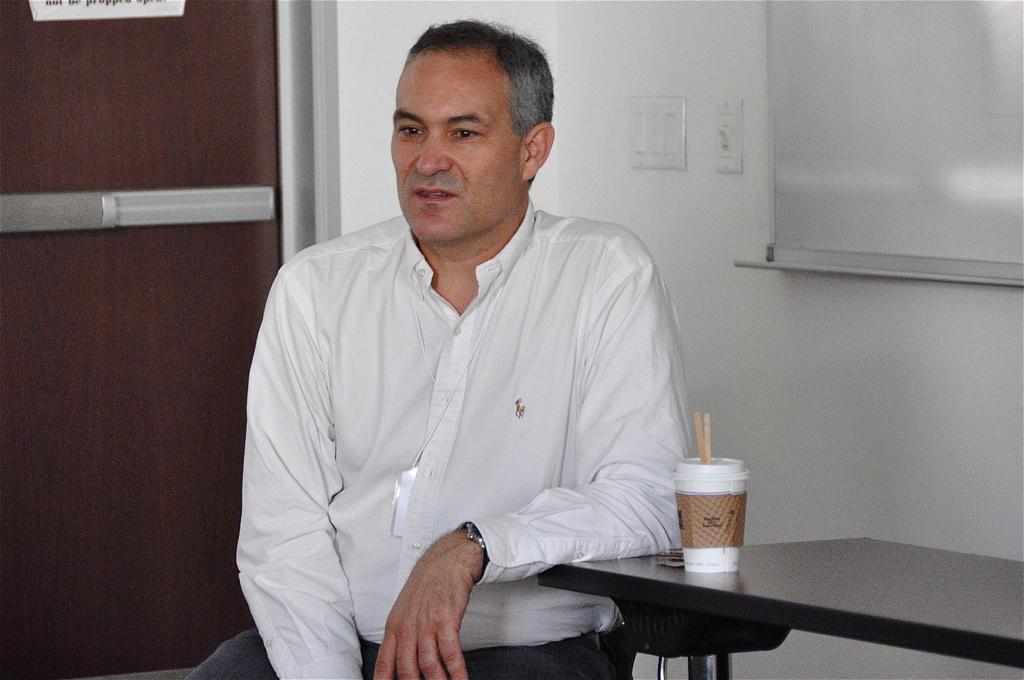What can be seen in the image? There is a person in the image. What is the person wearing? The person is wearing a white shirt and a watch. What is the person doing in the image? The person is sitting. What is near the person? There is a table near the person. What is on the table? There is a glass on the table. What can be seen in the background? There is a wall with a board and switches in the background. How many clocks are hanging on the wall in the image? There are no clocks visible on the wall in the image. What type of thing is on the shelf in the image? There is no shelf present in the image. 